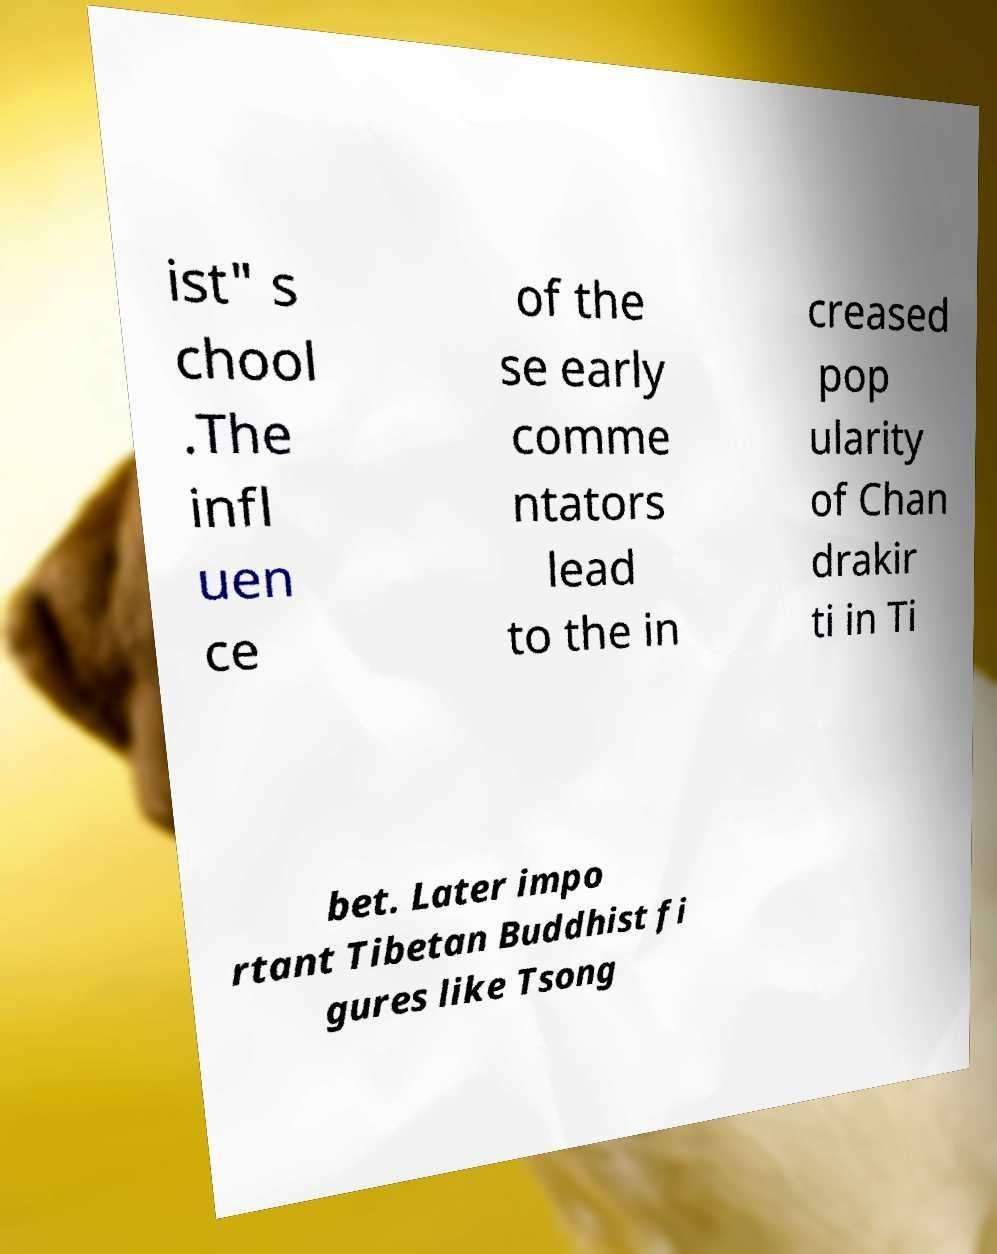Can you accurately transcribe the text from the provided image for me? ist" s chool .The infl uen ce of the se early comme ntators lead to the in creased pop ularity of Chan drakir ti in Ti bet. Later impo rtant Tibetan Buddhist fi gures like Tsong 